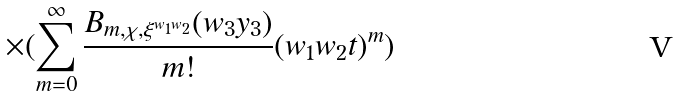Convert formula to latex. <formula><loc_0><loc_0><loc_500><loc_500>\times ( \sum _ { m = 0 } ^ { \infty } \frac { B _ { m , \chi , \xi ^ { w _ { 1 } w _ { 2 } } } ( w _ { 3 } y _ { 3 } ) } { m ! } ( w _ { 1 } w _ { 2 } t ) ^ { m } ) \\</formula> 